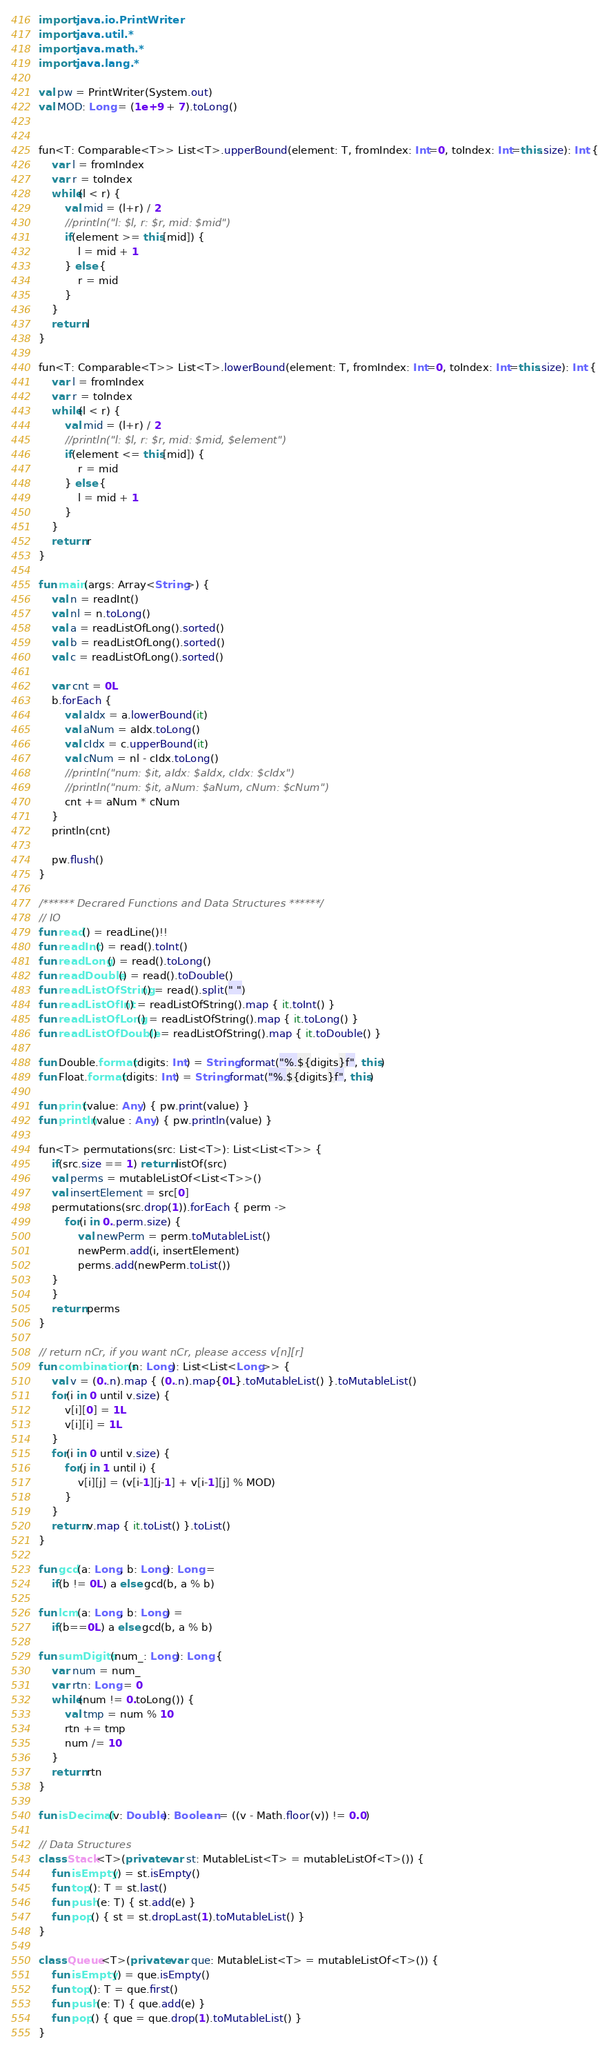<code> <loc_0><loc_0><loc_500><loc_500><_Kotlin_>import java.io.PrintWriter
import java.util.*
import java.math.*
import java.lang.*

val pw = PrintWriter(System.out)
val MOD: Long = (1e+9 + 7).toLong()


fun<T: Comparable<T>> List<T>.upperBound(element: T, fromIndex: Int=0, toIndex: Int=this.size): Int {
    var l = fromIndex
    var r = toIndex
    while(l < r) {
        val mid = (l+r) / 2
        //println("l: $l, r: $r, mid: $mid")
        if(element >= this[mid]) { 
            l = mid + 1
        } else {
            r = mid
        }
    }
    return l
}

fun<T: Comparable<T>> List<T>.lowerBound(element: T, fromIndex: Int=0, toIndex: Int=this.size): Int {
    var l = fromIndex
    var r = toIndex
    while(l < r) {
        val mid = (l+r) / 2
        //println("l: $l, r: $r, mid: $mid, $element")
        if(element <= this[mid]) { 
            r = mid
        } else {
            l = mid + 1
        }
    }
    return r 
}

fun main(args: Array<String>) {
    val n = readInt()
    val nl = n.toLong()
    val a = readListOfLong().sorted()
    val b = readListOfLong().sorted()
    val c = readListOfLong().sorted()

    var cnt = 0L
    b.forEach {
        val aIdx = a.lowerBound(it)
        val aNum = aIdx.toLong()
        val cIdx = c.upperBound(it)
        val cNum = nl - cIdx.toLong()
        //println("num: $it, aIdx: $aIdx, cIdx: $cIdx")
        //println("num: $it, aNum: $aNum, cNum: $cNum")
        cnt += aNum * cNum
    }
    println(cnt)
    
    pw.flush()
}

/****** Decrared Functions and Data Structures ******/
// IO
fun read() = readLine()!!
fun readInt() = read().toInt()
fun readLong() = read().toLong()
fun readDouble() = read().toDouble()
fun readListOfString() = read().split(" ")
fun readListOfInt() = readListOfString().map { it.toInt() }
fun readListOfLong() = readListOfString().map { it.toLong() }
fun readListOfDouble() = readListOfString().map { it.toDouble() }

fun Double.format(digits: Int) = String.format("%.${digits}f", this)
fun Float.format(digits: Int) = String.format("%.${digits}f", this)

fun print(value: Any) { pw.print(value) }
fun println(value : Any) { pw.println(value) }

fun<T> permutations(src: List<T>): List<List<T>> {
    if(src.size == 1) return listOf(src)
    val perms = mutableListOf<List<T>>()
    val insertElement = src[0]
    permutations(src.drop(1)).forEach { perm ->
        for(i in 0..perm.size) {
            val newPerm = perm.toMutableList()
            newPerm.add(i, insertElement)
            perms.add(newPerm.toList())
    }
    }
    return perms
}

// return nCr, if you want nCr, please access v[n][r]
fun combinations(n: Long): List<List<Long>> {
    val v = (0..n).map { (0..n).map{0L}.toMutableList() }.toMutableList()
    for(i in 0 until v.size) {
        v[i][0] = 1L
        v[i][i] = 1L
    }
    for(i in 0 until v.size) {
        for(j in 1 until i) {
            v[i][j] = (v[i-1][j-1] + v[i-1][j] % MOD)
        }
    }
    return v.map { it.toList() }.toList()
}

fun gcd(a: Long, b: Long): Long = 
    if(b != 0L) a else gcd(b, a % b)

fun lcm(a: Long, b: Long) = 
    if(b==0L) a else gcd(b, a % b)

fun sumDigits(num_: Long): Long {
    var num = num_
    var rtn: Long = 0
    while(num != 0.toLong()) {
        val tmp = num % 10
        rtn += tmp
        num /= 10
    }
    return rtn
}

fun isDecimal(v: Double): Boolean = ((v - Math.floor(v)) != 0.0)

// Data Structures
class Stack<T>(private var st: MutableList<T> = mutableListOf<T>()) {
    fun isEmpty() = st.isEmpty()
    fun top(): T = st.last()
    fun push(e: T) { st.add(e) }
    fun pop() { st = st.dropLast(1).toMutableList() }
}

class Queue<T>(private var que: MutableList<T> = mutableListOf<T>()) {
    fun isEmpty() = que.isEmpty()
    fun top(): T = que.first()
    fun push(e: T) { que.add(e) }
    fun pop() { que = que.drop(1).toMutableList() }
}
</code> 